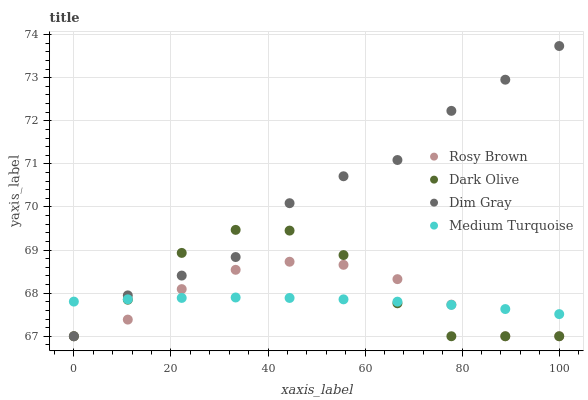Does Medium Turquoise have the minimum area under the curve?
Answer yes or no. Yes. Does Dim Gray have the maximum area under the curve?
Answer yes or no. Yes. Does Rosy Brown have the minimum area under the curve?
Answer yes or no. No. Does Rosy Brown have the maximum area under the curve?
Answer yes or no. No. Is Medium Turquoise the smoothest?
Answer yes or no. Yes. Is Dark Olive the roughest?
Answer yes or no. Yes. Is Dim Gray the smoothest?
Answer yes or no. No. Is Dim Gray the roughest?
Answer yes or no. No. Does Dark Olive have the lowest value?
Answer yes or no. Yes. Does Medium Turquoise have the lowest value?
Answer yes or no. No. Does Dim Gray have the highest value?
Answer yes or no. Yes. Does Rosy Brown have the highest value?
Answer yes or no. No. Does Dim Gray intersect Dark Olive?
Answer yes or no. Yes. Is Dim Gray less than Dark Olive?
Answer yes or no. No. Is Dim Gray greater than Dark Olive?
Answer yes or no. No. 